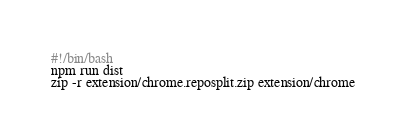Convert code to text. <code><loc_0><loc_0><loc_500><loc_500><_Bash_>#!/bin/bash
npm run dist
zip -r extension/chrome.reposplit.zip extension/chrome
</code> 